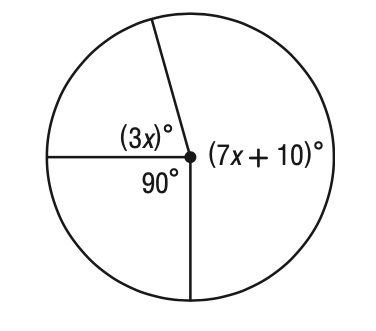Answer the mathemtical geometry problem and directly provide the correct option letter.
Question: What is the value of x in the figure?
Choices: A: 19 B: 23 C: 26 D: 28 C 